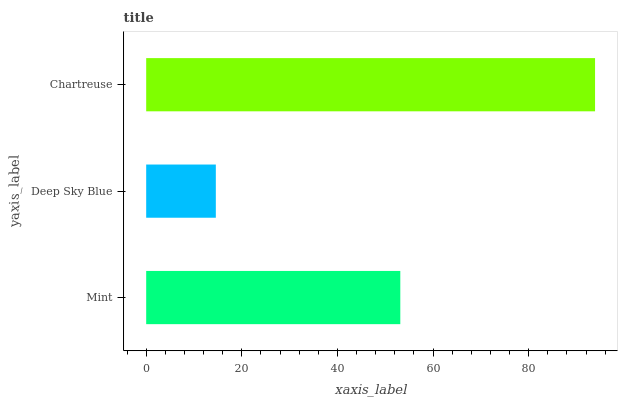Is Deep Sky Blue the minimum?
Answer yes or no. Yes. Is Chartreuse the maximum?
Answer yes or no. Yes. Is Chartreuse the minimum?
Answer yes or no. No. Is Deep Sky Blue the maximum?
Answer yes or no. No. Is Chartreuse greater than Deep Sky Blue?
Answer yes or no. Yes. Is Deep Sky Blue less than Chartreuse?
Answer yes or no. Yes. Is Deep Sky Blue greater than Chartreuse?
Answer yes or no. No. Is Chartreuse less than Deep Sky Blue?
Answer yes or no. No. Is Mint the high median?
Answer yes or no. Yes. Is Mint the low median?
Answer yes or no. Yes. Is Deep Sky Blue the high median?
Answer yes or no. No. Is Deep Sky Blue the low median?
Answer yes or no. No. 